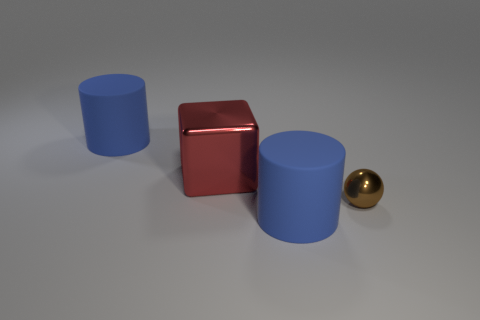What number of small brown balls are behind the large red metallic block?
Your response must be concise. 0. Are there any blue cylinders that have the same size as the red shiny thing?
Your answer should be very brief. Yes. There is a metal object right of the red thing; is its shape the same as the big red shiny object?
Ensure brevity in your answer.  No. The big metal block is what color?
Provide a short and direct response. Red. Are there any small purple metallic blocks?
Make the answer very short. No. There is a block that is the same material as the tiny brown sphere; what size is it?
Your answer should be very brief. Large. What is the shape of the object that is to the right of the matte cylinder on the right side of the big thing that is left of the big metallic object?
Give a very brief answer. Sphere. Is the number of matte things on the right side of the red shiny cube the same as the number of big blue metal spheres?
Your answer should be very brief. No. Do the brown thing and the large metal object have the same shape?
Keep it short and to the point. No. What number of objects are rubber cylinders in front of the brown shiny object or small cyan shiny things?
Offer a terse response. 1. 